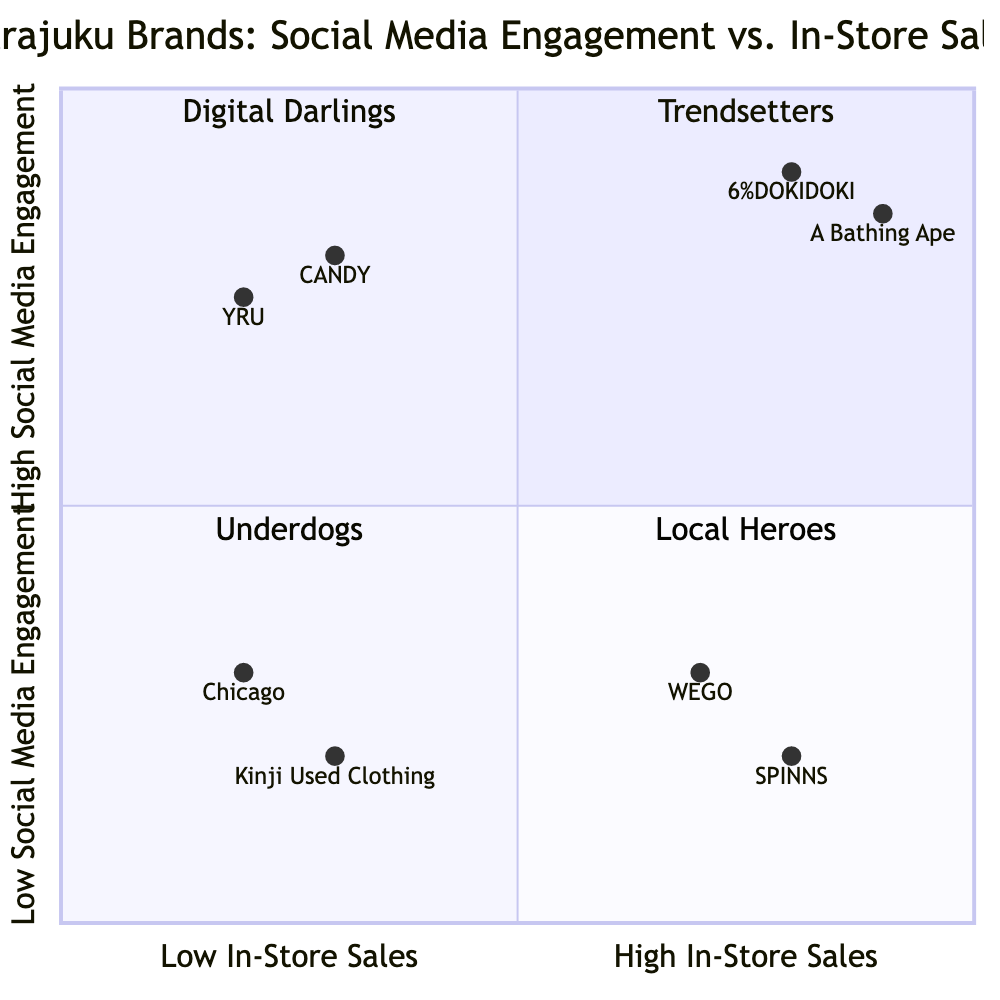What brands are in the Trendsetters quadrant? The Trendsetters quadrant contains brands that have high social media engagement and high in-store sales. From the data provided, the brands listed under this quadrant are 6%DOKIDOKI and A Bathing Ape.
Answer: 6%DOKIDOKI, A Bathing Ape How many brands fall into the Digital Darlings quadrant? The Digital Darlings quadrant is identified as having high social media engagement but low in-store sales. There are two brands listed in this quadrant: CANDY and YRU. Therefore, the total count of brands in this quadrant is 2.
Answer: 2 Which brand has the lowest social media engagement? To find the brand with the lowest social media engagement, we examine the engagement scores across all brands. The brand Kinji Used Clothing has a social media engagement score of 0.2, which is the lowest among all listed brands.
Answer: Kinji Used Clothing What can be inferred about WEGO's market strategy? WEGO is categorized under the Local Heroes quadrant, indicating it enjoys high in-store sales but low social media engagement. This suggests that WEGO relies more on traditional retail strategies, focusing on local customer promotions rather than digital marketing.
Answer: Traditional retail focus Identify the brands in the Underdogs quadrant. The Underdogs quadrant includes brands with both low social media engagement and low in-store sales. Based on the information, the brands in this quadrant are Chicago and Kinji Used Clothing.
Answer: Chicago, Kinji Used Clothing How does A Bathing Ape compare to CANDY in terms of engagement and sales? A Bathing Ape is located in the Trendsetters quadrant with both high engagement and high sales, while CANDY is in the Digital Darlings quadrant with high engagement but low sales. This comparison shows that A Bathing Ape outperforms CANDY in terms of both metrics.
Answer: A Bathing Ape outperforms CANDY What is the engagement score of SPINNS? SPINNS, positioned in the Local Heroes quadrant, has a social media engagement score of 0.2 according to the data provided.
Answer: 0.2 Categorize the brands by highest to lowest sales score based on the data. Analyzing the in-store sales scores from the highest to lowest, we have the following order: A Bathing Ape (0.9), 6%DOKIDOKI (0.8), SPINNS (0.8), WEGO (0.7), CANDY (0.3), Kinji Used Clothing (0.3), Chicago (0.2), and YRU (0.2).
Answer: A Bathing Ape, 6%DOKIDOKI, SPINNS, WEGO, CANDY, Kinji Used Clothing, Chicago, YRU Which quadrant does YRU belong to? YRU is categorized under the Digital Darlings quadrant, which is characterized by high social media engagement and low in-store sales.
Answer: Digital Darlings 